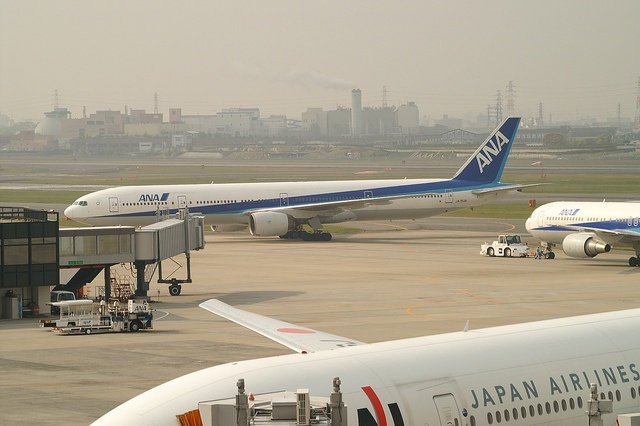Describe the objects in this image and their specific colors. I can see airplane in lightgray, darkgray, beige, and gray tones, airplane in lightgray, gray, darkgray, and darkblue tones, airplane in lightgray, beige, darkgray, and gray tones, truck in lightgray, gray, black, and darkgray tones, and truck in lightgray, beige, darkgray, gray, and tan tones in this image. 